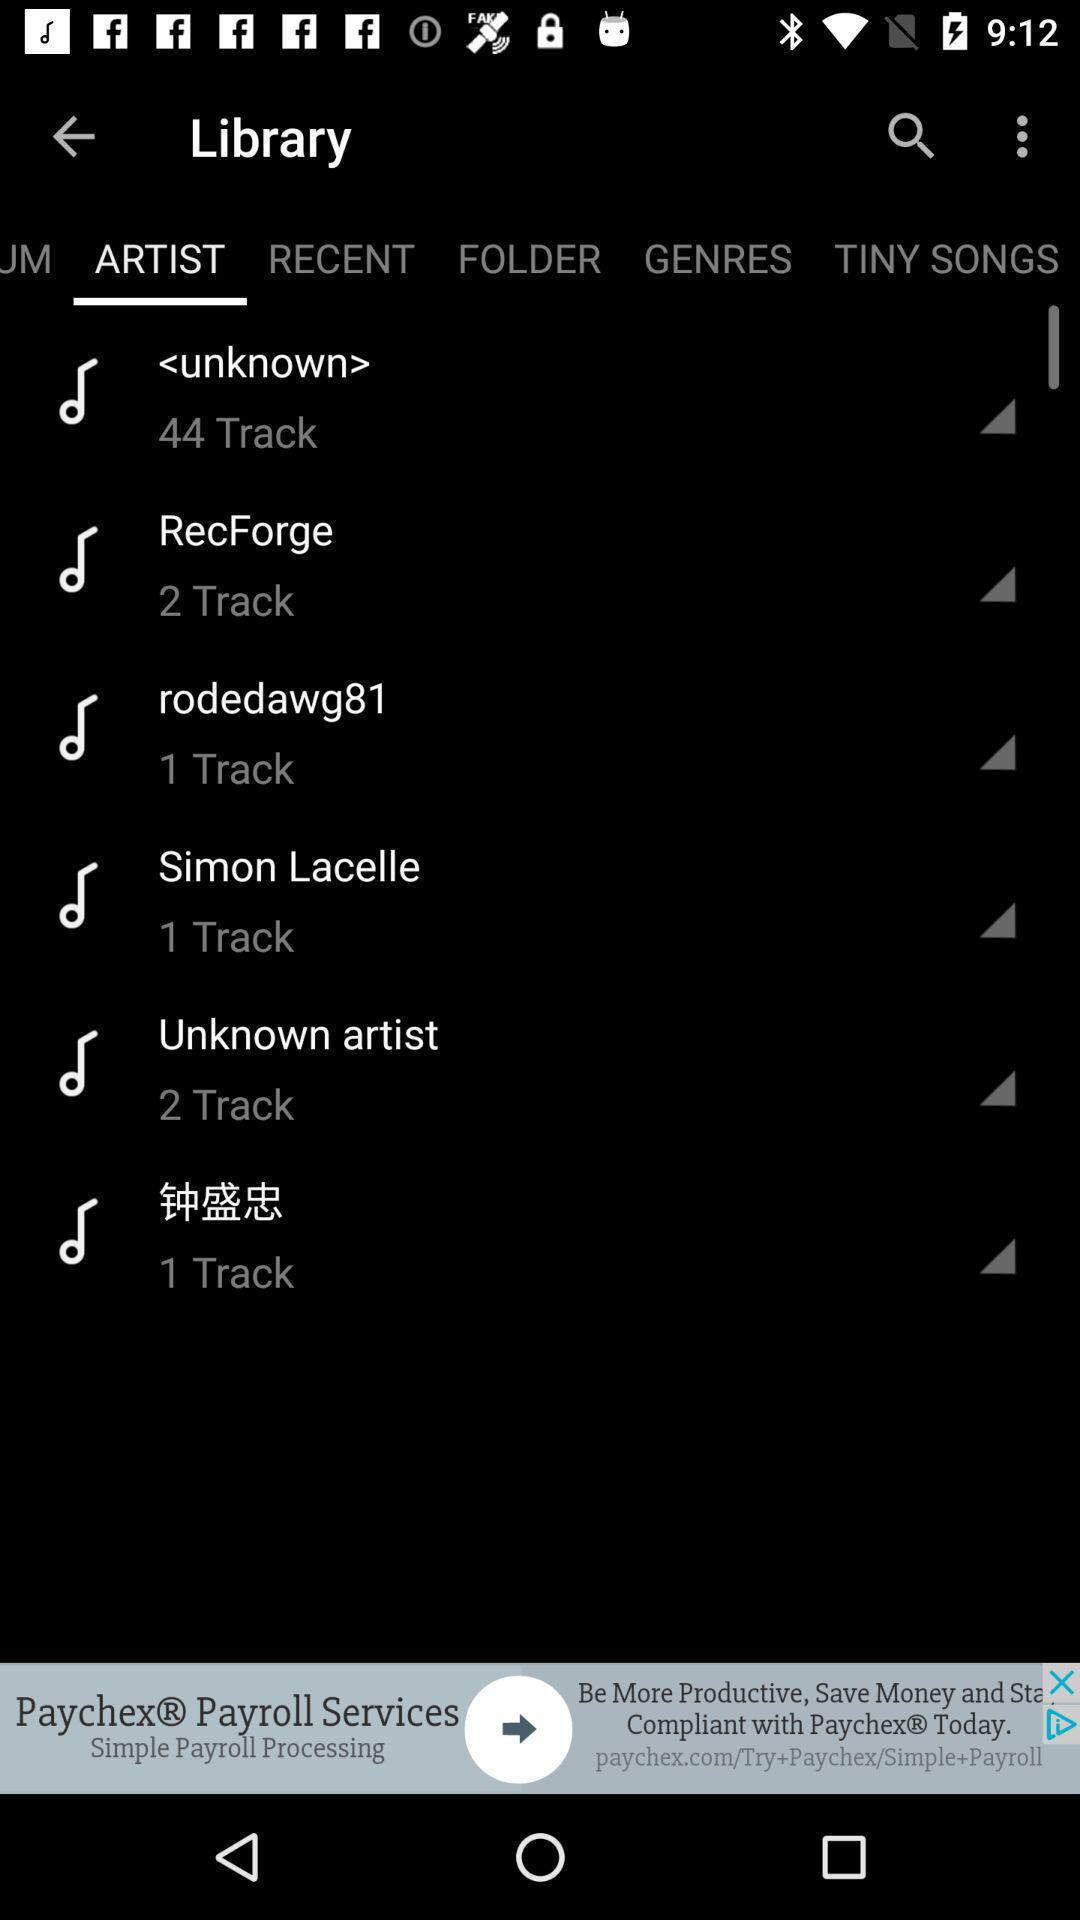What is the number of tracks present in "Simon Lacelle"? The number of tracks is 1. 